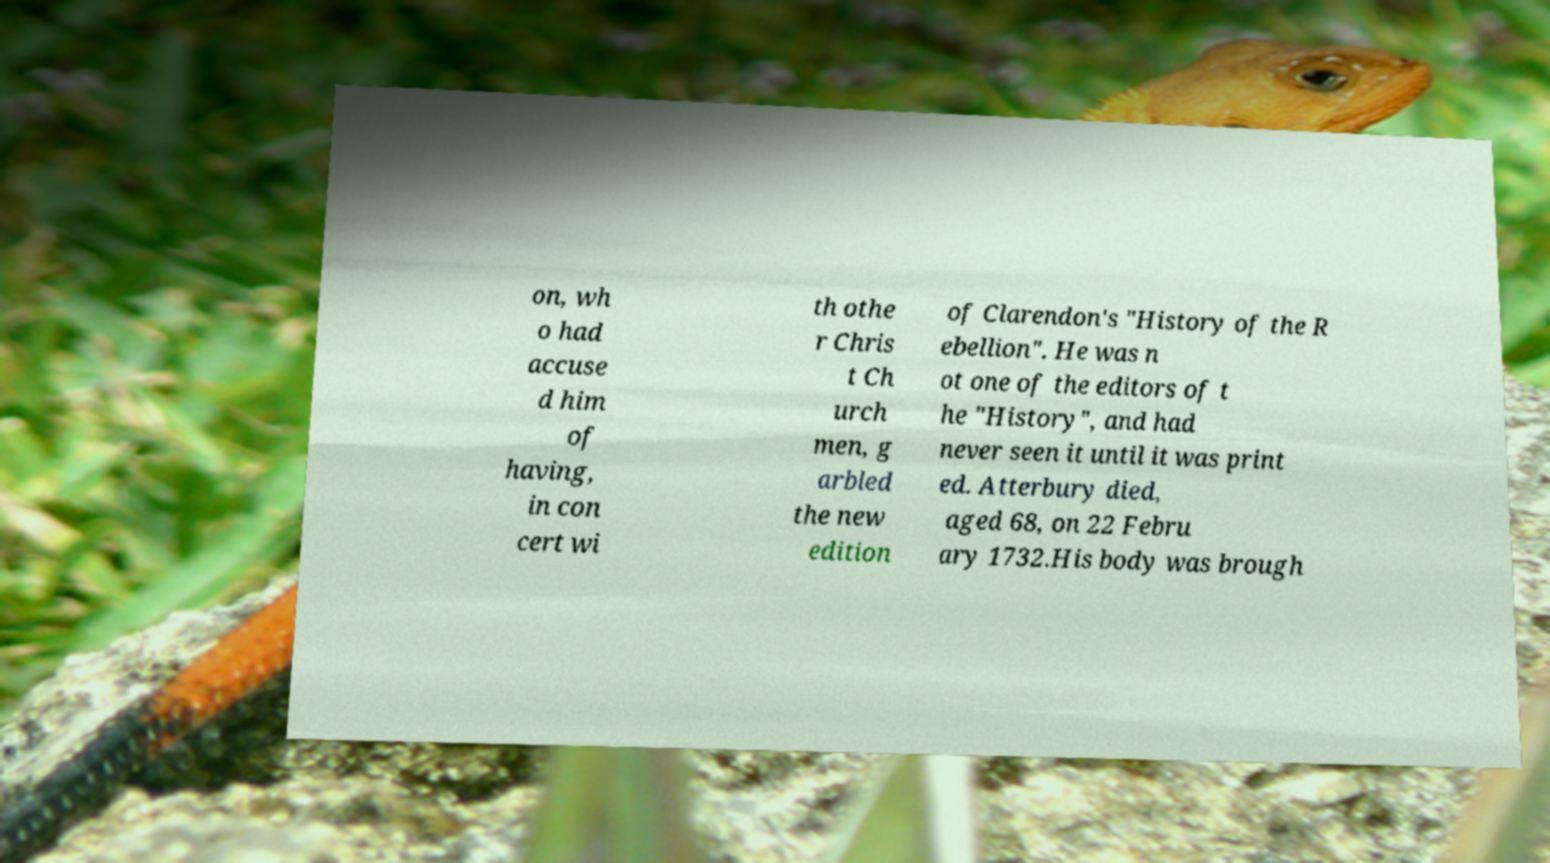Can you read and provide the text displayed in the image?This photo seems to have some interesting text. Can you extract and type it out for me? on, wh o had accuse d him of having, in con cert wi th othe r Chris t Ch urch men, g arbled the new edition of Clarendon's "History of the R ebellion". He was n ot one of the editors of t he "History", and had never seen it until it was print ed. Atterbury died, aged 68, on 22 Febru ary 1732.His body was brough 